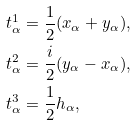<formula> <loc_0><loc_0><loc_500><loc_500>t ^ { 1 } _ { \alpha } & = \frac { 1 } { 2 } ( x _ { \alpha } + y _ { \alpha } ) , \\ t ^ { 2 } _ { \alpha } & = \frac { i } { 2 } ( y _ { \alpha } - x _ { \alpha } ) , \\ t ^ { 3 } _ { \alpha } & = \frac { 1 } { 2 } h _ { \alpha } ,</formula> 